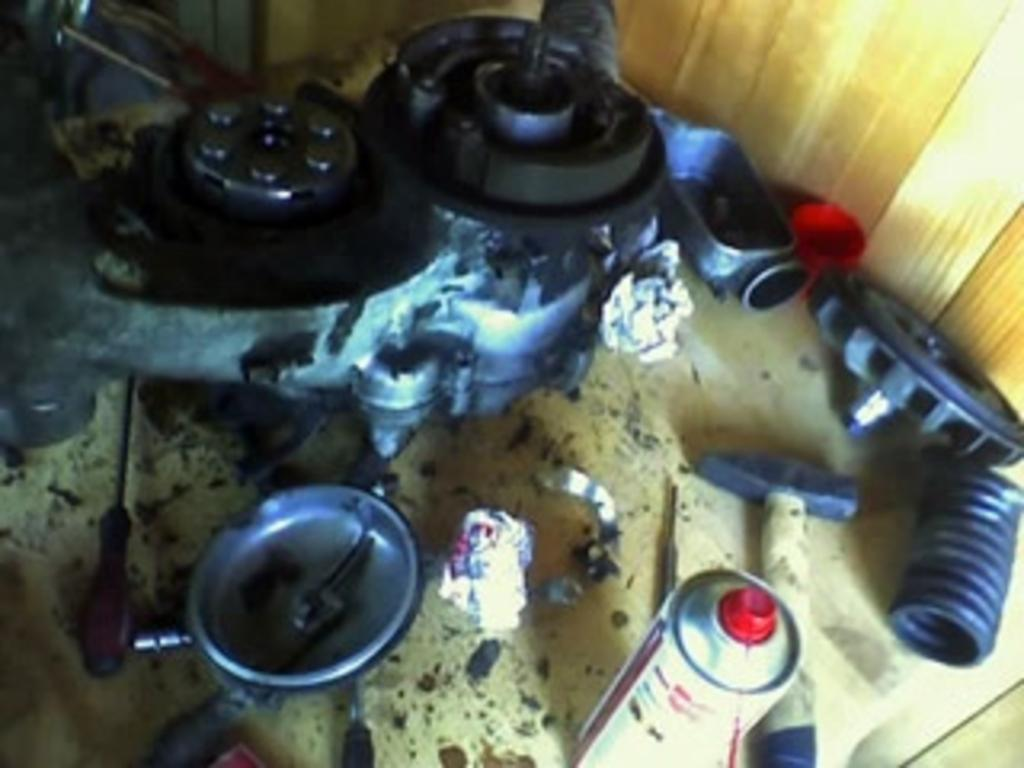What tools can be seen in the image? There is a screwdriver and a hammer in the image. What else is present in the image besides the tools? There are some objects in the image. Can you describe the background of the image? There appears to be a wooden wall in the top right corner of the image. What type of music can be heard coming from the mice in the image? There are no mice present in the image, and therefore no music can be heard. 